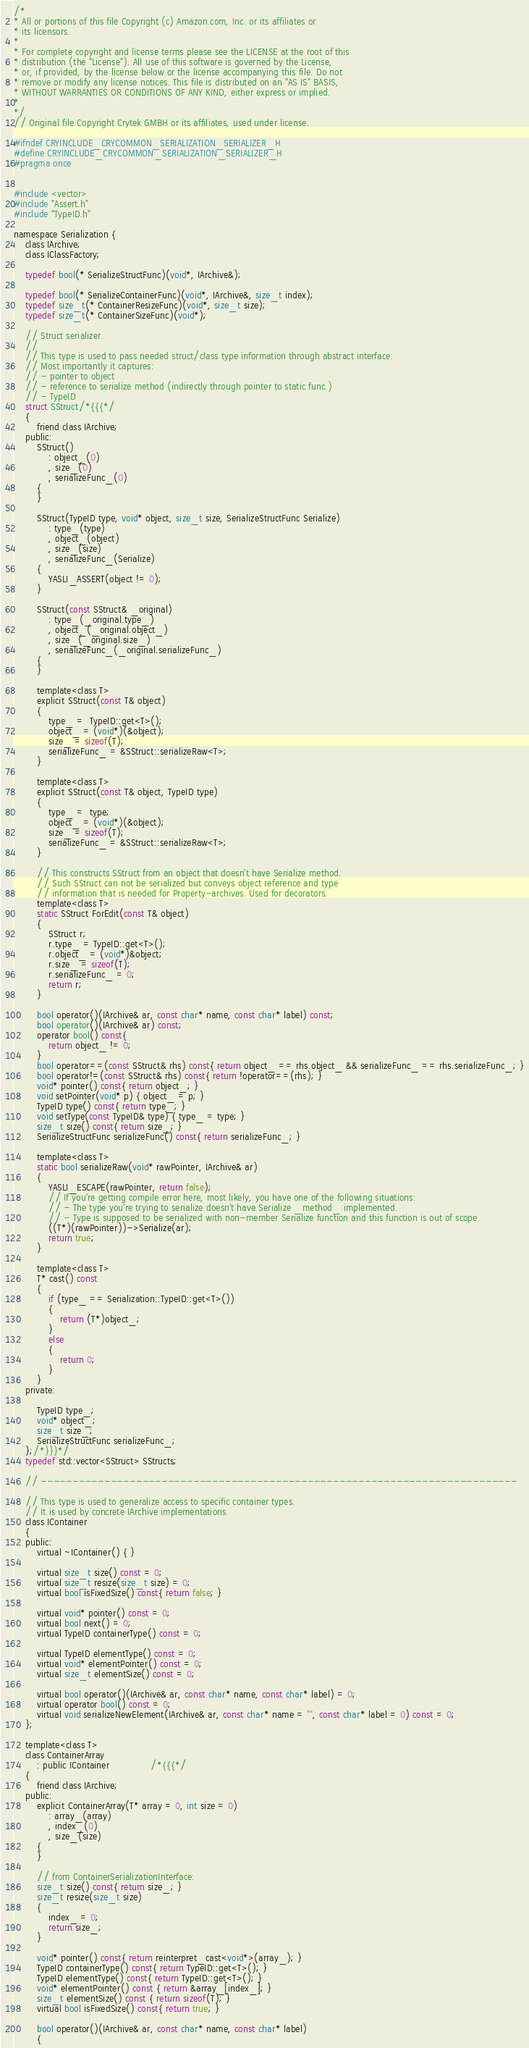Convert code to text. <code><loc_0><loc_0><loc_500><loc_500><_C_>/*
* All or portions of this file Copyright (c) Amazon.com, Inc. or its affiliates or
* its licensors.
*
* For complete copyright and license terms please see the LICENSE at the root of this
* distribution (the "License"). All use of this software is governed by the License,
* or, if provided, by the license below or the license accompanying this file. Do not
* remove or modify any license notices. This file is distributed on an "AS IS" BASIS,
* WITHOUT WARRANTIES OR CONDITIONS OF ANY KIND, either express or implied.
*
*/
// Original file Copyright Crytek GMBH or its affiliates, used under license.

#ifndef CRYINCLUDE_CRYCOMMON_SERIALIZATION_SERIALIZER_H
#define CRYINCLUDE_CRYCOMMON_SERIALIZATION_SERIALIZER_H
#pragma once


#include <vector>
#include "Assert.h"
#include "TypeID.h"

namespace Serialization {
    class IArchive;
    class IClassFactory;

    typedef bool(* SerializeStructFunc)(void*, IArchive&);

    typedef bool(* SerializeContainerFunc)(void*, IArchive&, size_t index);
    typedef size_t(* ContainerResizeFunc)(void*, size_t size);
    typedef size_t(* ContainerSizeFunc)(void*);

    // Struct serializer.
    //
    // This type is used to pass needed struct/class type information through abstract interface.
    // Most importantly it captures:
    // - pointer to object
    // - reference to serialize method (indirectly through pointer to static func.)
    // - TypeID
    struct SStruct/*{{{*/
    {
        friend class IArchive;
    public:
        SStruct()
            : object_(0)
            , size_(0)
            , serializeFunc_(0)
        {
        }

        SStruct(TypeID type, void* object, size_t size, SerializeStructFunc Serialize)
            : type_(type)
            , object_(object)
            , size_(size)
            , serializeFunc_(Serialize)
        {
            YASLI_ASSERT(object != 0);
        }

        SStruct(const SStruct& _original)
            : type_(_original.type_)
            , object_(_original.object_)
            , size_(_original.size_)
            , serializeFunc_(_original.serializeFunc_)
        {
        }

        template<class T>
        explicit SStruct(const T& object)
        {
            type_ =  TypeID::get<T>();
            object_ = (void*)(&object);
            size_ = sizeof(T);
            serializeFunc_ = &SStruct::serializeRaw<T>;
        }

        template<class T>
        explicit SStruct(const T& object, TypeID type)
        {
            type_ =  type;
            object_ = (void*)(&object);
            size_ = sizeof(T);
            serializeFunc_ = &SStruct::serializeRaw<T>;
        }

        // This constructs SStruct from an object that doesn't have Serialize method.
        // Such SStruct can not be serialized but conveys object reference and type
        // information that is needed for Property-archives. Used for decorators.
        template<class T>
        static SStruct ForEdit(const T& object)
        {
            SStruct r;
            r.type_ = TypeID::get<T>();
            r.object_ = (void*)&object;
            r.size_ = sizeof(T);
            r.serializeFunc_ = 0;
            return r;
        }

        bool operator()(IArchive& ar, const char* name, const char* label) const;
        bool operator()(IArchive& ar) const;
        operator bool() const{
            return object_ != 0;
        }
        bool operator==(const SStruct& rhs) const{ return object_ == rhs.object_ && serializeFunc_ == rhs.serializeFunc_; }
        bool operator!=(const SStruct& rhs) const{ return !operator==(rhs); }
        void* pointer() const{ return object_; }
        void setPointer(void* p) { object_ = p; }
        TypeID type() const{ return type_; }
        void setType(const TypeID& type) { type_ = type; }
        size_t size() const{ return size_; }
        SerializeStructFunc serializeFunc() const{ return serializeFunc_; }

        template<class T>
        static bool serializeRaw(void* rawPointer, IArchive& ar)
        {
            YASLI_ESCAPE(rawPointer, return false);
            // If you're getting compile error here, most likely, you have one of the following situations:
            // - The type you're trying to serialize doesn't have Serialize _method_ implemented.
            // - Type is supposed to be serialized with non-member Serialize function and this function is out of scope.
            ((T*)(rawPointer))->Serialize(ar);
            return true;
        }

        template<class T>
        T* cast() const
        {
            if (type_ == Serialization::TypeID::get<T>())
            {
                return (T*)object_;
            }
            else
            {
                return 0;
            }
        }
    private:

        TypeID type_;
        void* object_;
        size_t size_;
        SerializeStructFunc serializeFunc_;
    };/*}}}*/
    typedef std::vector<SStruct> SStructs;

    // ---------------------------------------------------------------------------

    // This type is used to generalize access to specific container types.
    // It is used by concrete IArchive implementations.
    class IContainer
    {
    public:
        virtual ~IContainer() { }

        virtual size_t size() const = 0;
        virtual size_t resize(size_t size) = 0;
        virtual bool isFixedSize() const{ return false; }

        virtual void* pointer() const = 0;
        virtual bool next() = 0;
        virtual TypeID containerType() const = 0;

        virtual TypeID elementType() const = 0;
        virtual void* elementPointer() const = 0;
        virtual size_t elementSize() const = 0;

        virtual bool operator()(IArchive& ar, const char* name, const char* label) = 0;
        virtual operator bool() const = 0;
        virtual void serializeNewElement(IArchive& ar, const char* name = "", const char* label = 0) const = 0;
    };

    template<class T>
    class ContainerArray
        : public IContainer              /*{{{*/
    {
        friend class IArchive;
    public:
        explicit ContainerArray(T* array = 0, int size = 0)
            : array_(array)
            , index_(0)
            , size_(size)
        {
        }

        // from ContainerSerializationInterface:
        size_t size() const{ return size_; }
        size_t resize(size_t size)
        {
            index_ = 0;
            return size_;
        }

        void* pointer() const{ return reinterpret_cast<void*>(array_); }
        TypeID containerType() const{ return TypeID::get<T>(); }
        TypeID elementType() const{ return TypeID::get<T>(); }
        void* elementPointer() const { return &array_[index_]; }
        size_t elementSize() const { return sizeof(T); }
        virtual bool isFixedSize() const{ return true; }

        bool operator()(IArchive& ar, const char* name, const char* label)
        {</code> 